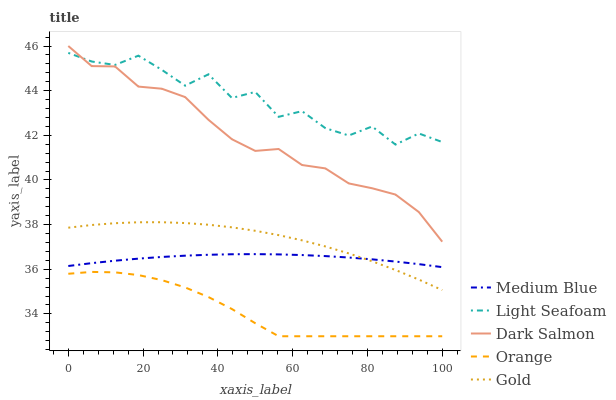Does Orange have the minimum area under the curve?
Answer yes or no. Yes. Does Light Seafoam have the maximum area under the curve?
Answer yes or no. Yes. Does Medium Blue have the minimum area under the curve?
Answer yes or no. No. Does Medium Blue have the maximum area under the curve?
Answer yes or no. No. Is Medium Blue the smoothest?
Answer yes or no. Yes. Is Light Seafoam the roughest?
Answer yes or no. Yes. Is Light Seafoam the smoothest?
Answer yes or no. No. Is Medium Blue the roughest?
Answer yes or no. No. Does Orange have the lowest value?
Answer yes or no. Yes. Does Medium Blue have the lowest value?
Answer yes or no. No. Does Dark Salmon have the highest value?
Answer yes or no. Yes. Does Light Seafoam have the highest value?
Answer yes or no. No. Is Orange less than Medium Blue?
Answer yes or no. Yes. Is Dark Salmon greater than Medium Blue?
Answer yes or no. Yes. Does Medium Blue intersect Gold?
Answer yes or no. Yes. Is Medium Blue less than Gold?
Answer yes or no. No. Is Medium Blue greater than Gold?
Answer yes or no. No. Does Orange intersect Medium Blue?
Answer yes or no. No. 